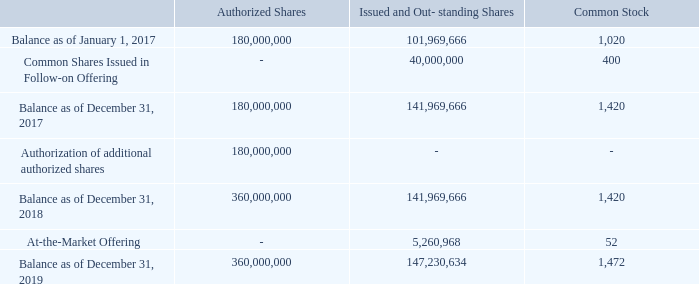14. SHAREHOLDERS’ EQUITY
Authorized, issued and outstanding common shares roll-forward is as follows:
In December 2017, the Company completed an underwritten public offering of 40,000,000 common shares which increased its equity by $103.7 million.
In December 2018, the Annual General Meeting of the Company approved to increase the Company’s authorized share capital from $1.8 million to $3.6 million.
During 2019, the Company has issued 5,260,968 shares through the ATM program and raised net proceeds of $17.9 million.
In December 2017, what was the increase in equity from the Company's underwritten public offering? $103.7 million. How many shares did the company issue in 2019 through the ATM program? 5,260,968 shares. What are the respective number of authorised shares as of December 31, 2018 and 2019? 360,000,000, 360,000,000. What is the value of the number of shares issued by the company in 2017 as a percentage of its total issued and outstanding shares as at December 31, 2017?
Answer scale should be: percent. 40,000,000/141,969,666 
Answer: 28.18. What is the value of the number of issued shares in 2019 as a percentage of the company's total issued and outstanding shares as at December 31, 2019?
Answer scale should be: percent. 5,260,968/147,230,634 
Answer: 3.57. What is the average number of authorised shares as at December 31, 2018 and 2019? (360,000,000 + 360,000,000)/2 
Answer: 360000000. 